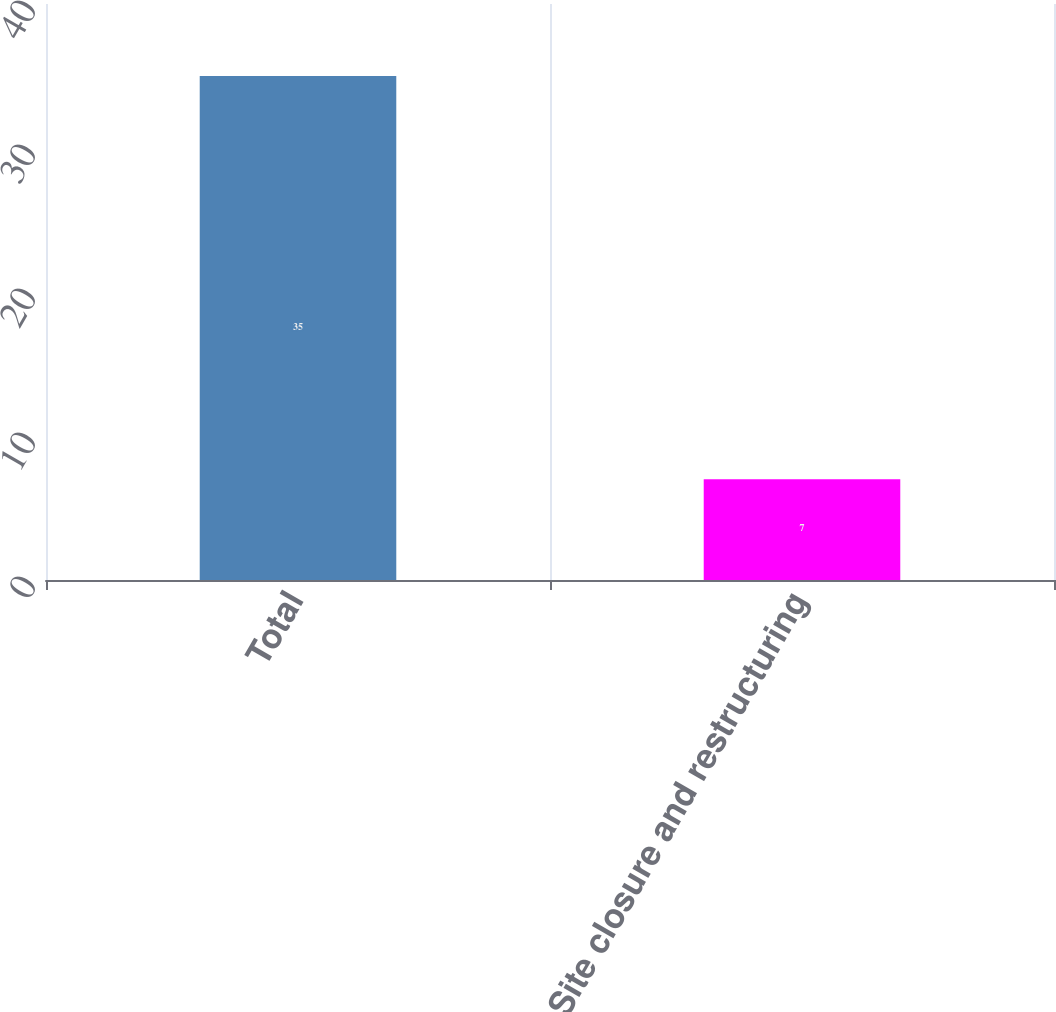Convert chart to OTSL. <chart><loc_0><loc_0><loc_500><loc_500><bar_chart><fcel>Total<fcel>Site closure and restructuring<nl><fcel>35<fcel>7<nl></chart> 